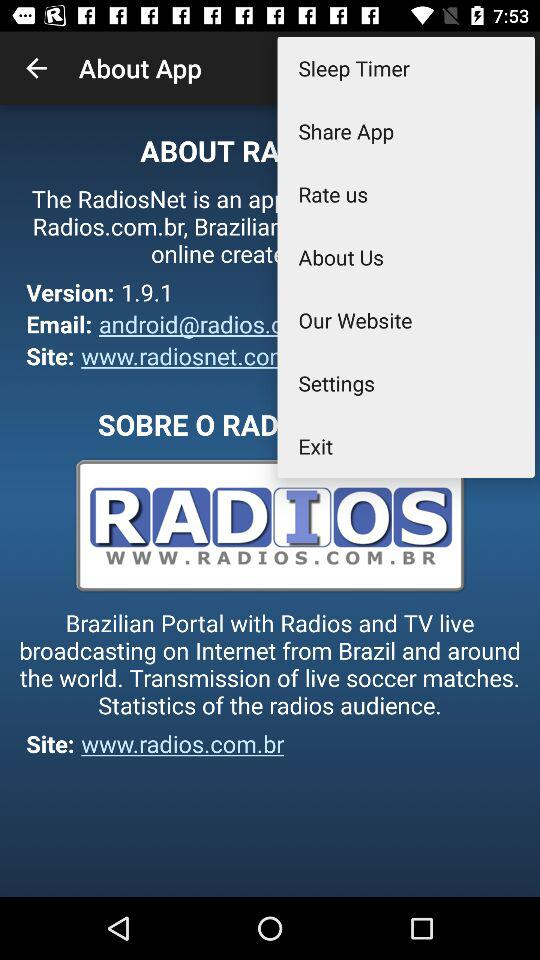What is the website? The website is www.radios.com.br. 